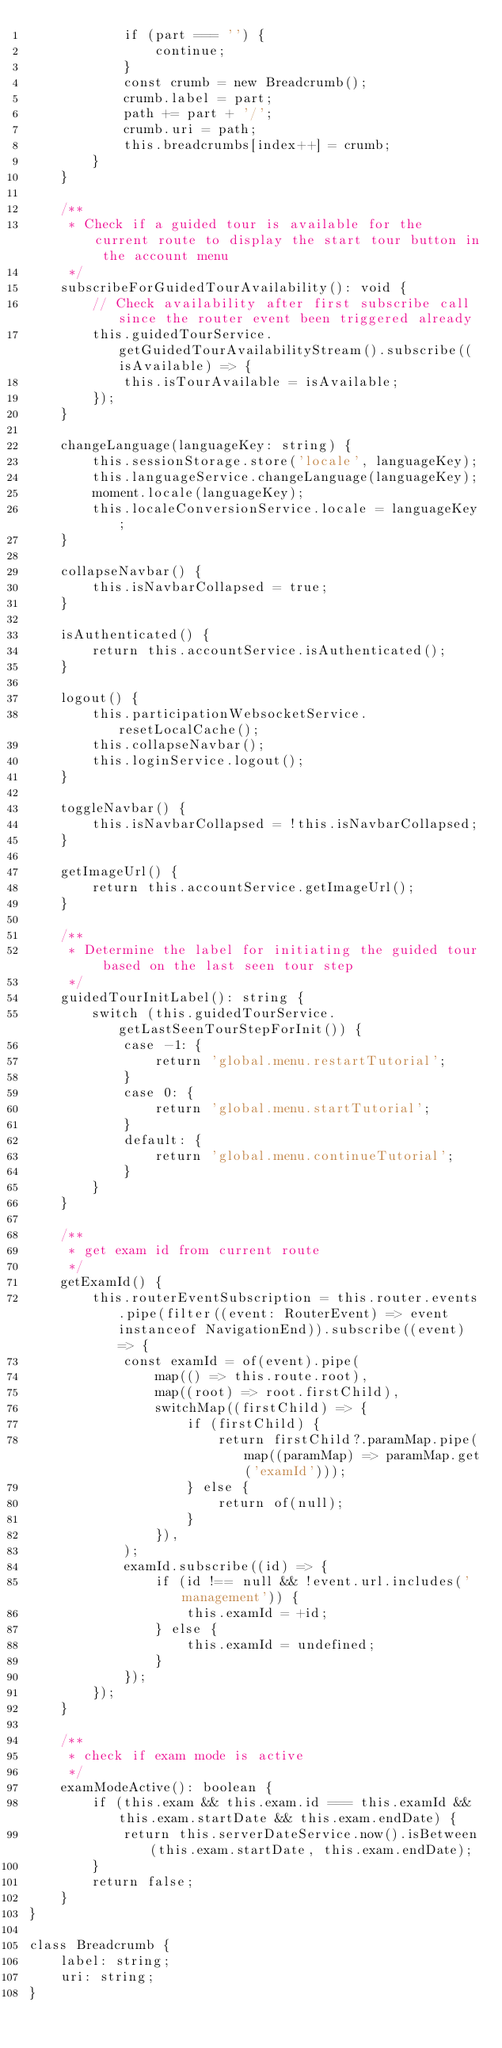Convert code to text. <code><loc_0><loc_0><loc_500><loc_500><_TypeScript_>            if (part === '') {
                continue;
            }
            const crumb = new Breadcrumb();
            crumb.label = part;
            path += part + '/';
            crumb.uri = path;
            this.breadcrumbs[index++] = crumb;
        }
    }

    /**
     * Check if a guided tour is available for the current route to display the start tour button in the account menu
     */
    subscribeForGuidedTourAvailability(): void {
        // Check availability after first subscribe call since the router event been triggered already
        this.guidedTourService.getGuidedTourAvailabilityStream().subscribe((isAvailable) => {
            this.isTourAvailable = isAvailable;
        });
    }

    changeLanguage(languageKey: string) {
        this.sessionStorage.store('locale', languageKey);
        this.languageService.changeLanguage(languageKey);
        moment.locale(languageKey);
        this.localeConversionService.locale = languageKey;
    }

    collapseNavbar() {
        this.isNavbarCollapsed = true;
    }

    isAuthenticated() {
        return this.accountService.isAuthenticated();
    }

    logout() {
        this.participationWebsocketService.resetLocalCache();
        this.collapseNavbar();
        this.loginService.logout();
    }

    toggleNavbar() {
        this.isNavbarCollapsed = !this.isNavbarCollapsed;
    }

    getImageUrl() {
        return this.accountService.getImageUrl();
    }

    /**
     * Determine the label for initiating the guided tour based on the last seen tour step
     */
    guidedTourInitLabel(): string {
        switch (this.guidedTourService.getLastSeenTourStepForInit()) {
            case -1: {
                return 'global.menu.restartTutorial';
            }
            case 0: {
                return 'global.menu.startTutorial';
            }
            default: {
                return 'global.menu.continueTutorial';
            }
        }
    }

    /**
     * get exam id from current route
     */
    getExamId() {
        this.routerEventSubscription = this.router.events.pipe(filter((event: RouterEvent) => event instanceof NavigationEnd)).subscribe((event) => {
            const examId = of(event).pipe(
                map(() => this.route.root),
                map((root) => root.firstChild),
                switchMap((firstChild) => {
                    if (firstChild) {
                        return firstChild?.paramMap.pipe(map((paramMap) => paramMap.get('examId')));
                    } else {
                        return of(null);
                    }
                }),
            );
            examId.subscribe((id) => {
                if (id !== null && !event.url.includes('management')) {
                    this.examId = +id;
                } else {
                    this.examId = undefined;
                }
            });
        });
    }

    /**
     * check if exam mode is active
     */
    examModeActive(): boolean {
        if (this.exam && this.exam.id === this.examId && this.exam.startDate && this.exam.endDate) {
            return this.serverDateService.now().isBetween(this.exam.startDate, this.exam.endDate);
        }
        return false;
    }
}

class Breadcrumb {
    label: string;
    uri: string;
}
</code> 